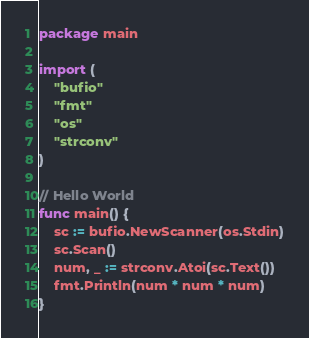<code> <loc_0><loc_0><loc_500><loc_500><_Go_>package main

import (
	"bufio"
	"fmt"
	"os"
	"strconv"
)

// Hello World
func main() {
	sc := bufio.NewScanner(os.Stdin)
	sc.Scan()
	num, _ := strconv.Atoi(sc.Text())
	fmt.Println(num * num * num)
}

</code> 